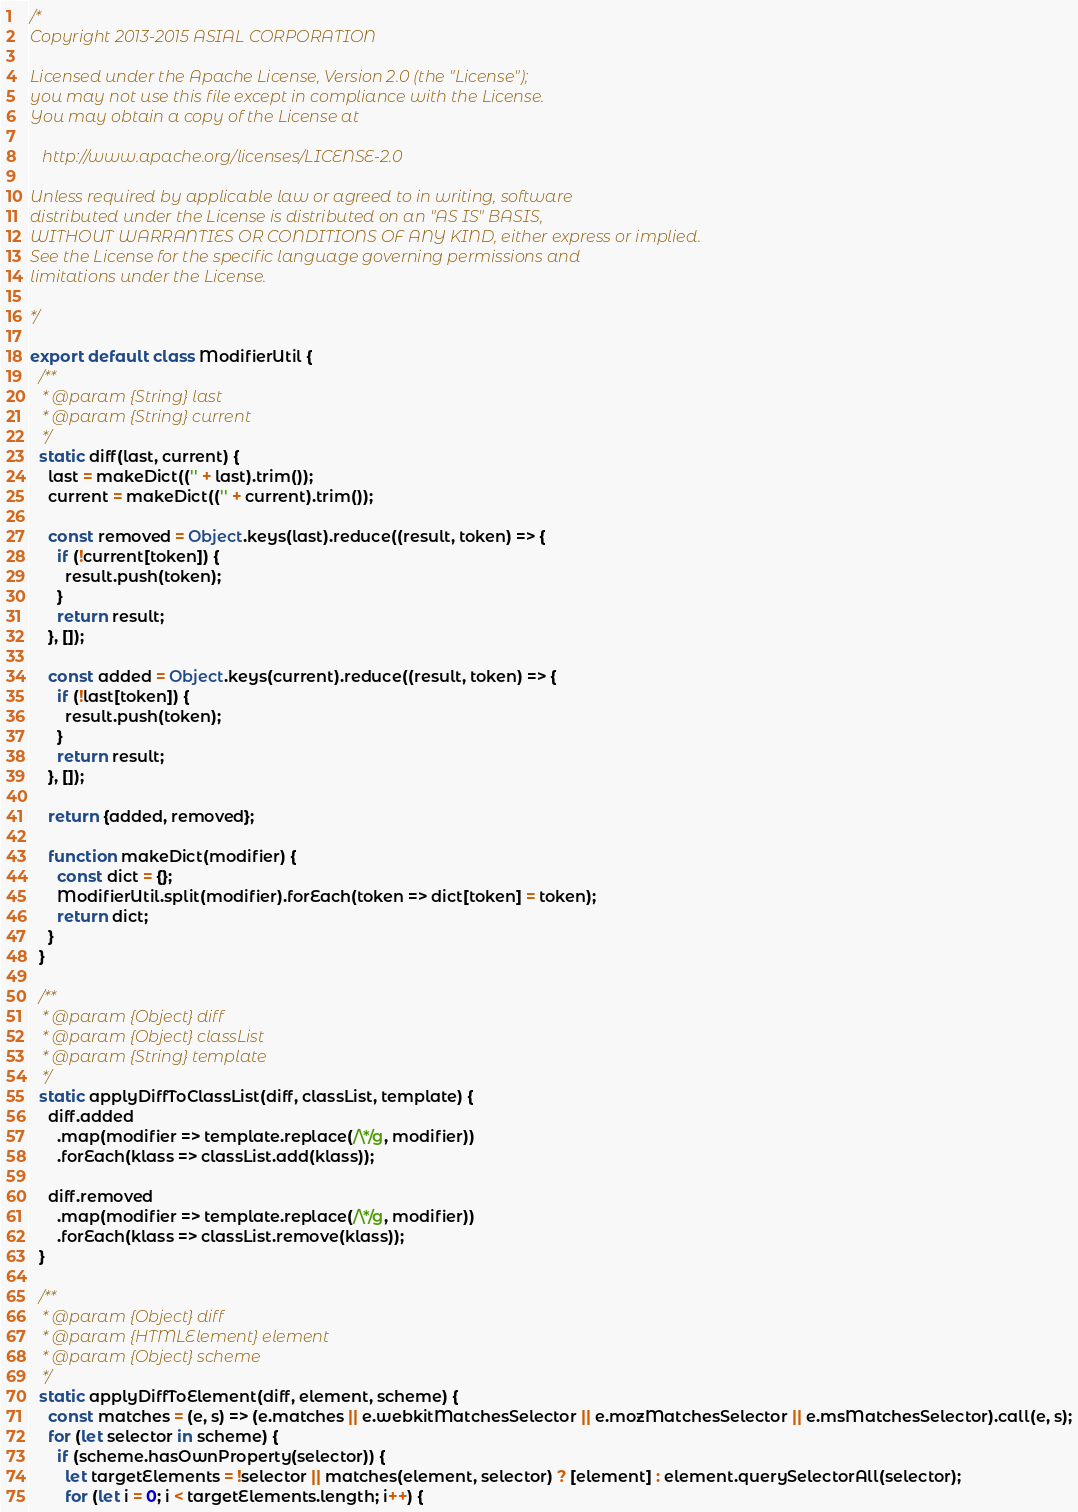<code> <loc_0><loc_0><loc_500><loc_500><_JavaScript_>/*
Copyright 2013-2015 ASIAL CORPORATION

Licensed under the Apache License, Version 2.0 (the "License");
you may not use this file except in compliance with the License.
You may obtain a copy of the License at

   http://www.apache.org/licenses/LICENSE-2.0

Unless required by applicable law or agreed to in writing, software
distributed under the License is distributed on an "AS IS" BASIS,
WITHOUT WARRANTIES OR CONDITIONS OF ANY KIND, either express or implied.
See the License for the specific language governing permissions and
limitations under the License.

*/

export default class ModifierUtil {
  /**
   * @param {String} last
   * @param {String} current
   */
  static diff(last, current) {
    last = makeDict(('' + last).trim());
    current = makeDict(('' + current).trim());

    const removed = Object.keys(last).reduce((result, token) => {
      if (!current[token]) {
        result.push(token);
      }
      return result;
    }, []);

    const added = Object.keys(current).reduce((result, token) => {
      if (!last[token]) {
        result.push(token);
      }
      return result;
    }, []);

    return {added, removed};

    function makeDict(modifier) {
      const dict = {};
      ModifierUtil.split(modifier).forEach(token => dict[token] = token);
      return dict;
    }
  }

  /**
   * @param {Object} diff
   * @param {Object} classList
   * @param {String} template
   */
  static applyDiffToClassList(diff, classList, template) {
    diff.added
      .map(modifier => template.replace(/\*/g, modifier))
      .forEach(klass => classList.add(klass));

    diff.removed
      .map(modifier => template.replace(/\*/g, modifier))
      .forEach(klass => classList.remove(klass));
  }

  /**
   * @param {Object} diff
   * @param {HTMLElement} element
   * @param {Object} scheme
   */
  static applyDiffToElement(diff, element, scheme) {
    const matches = (e, s) => (e.matches || e.webkitMatchesSelector || e.mozMatchesSelector || e.msMatchesSelector).call(e, s);
    for (let selector in scheme) {
      if (scheme.hasOwnProperty(selector)) {
        let targetElements = !selector || matches(element, selector) ? [element] : element.querySelectorAll(selector);
        for (let i = 0; i < targetElements.length; i++) {</code> 